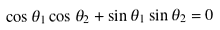Convert formula to latex. <formula><loc_0><loc_0><loc_500><loc_500>\cos \theta _ { 1 } \cos \theta _ { 2 } + \sin \theta _ { 1 } \sin \theta _ { 2 } = 0</formula> 